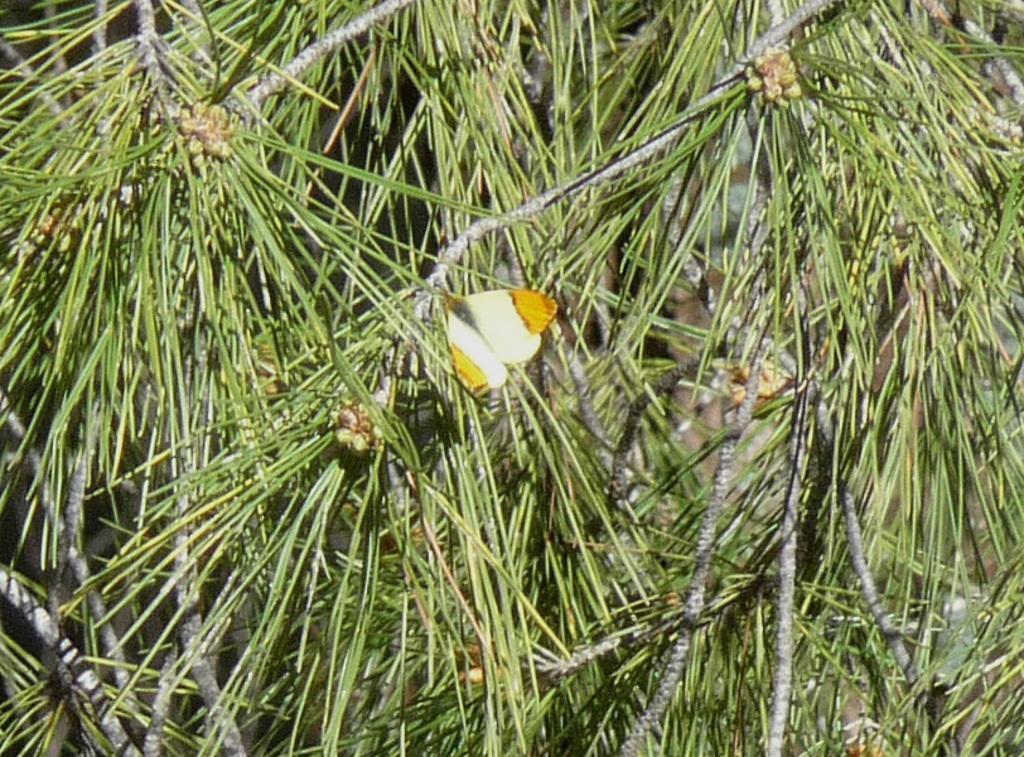Describe this image in one or two sentences. In this picture we can see a butterfly and plants. 